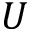<formula> <loc_0><loc_0><loc_500><loc_500>U</formula> 